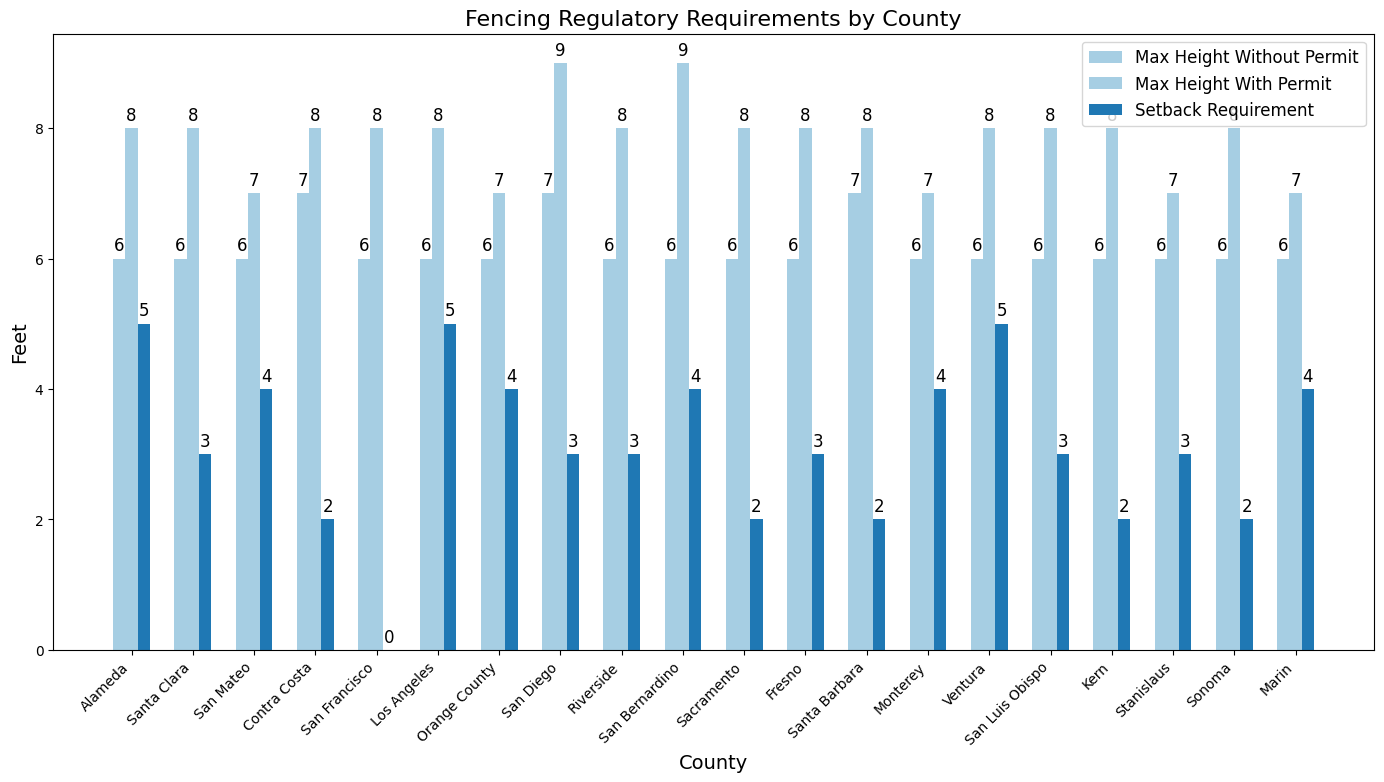How many counties have a setback requirement of 3 feet? To find this, count the number of bars representing 3 feet in height for the "Setback Requirement" across all counties.
Answer: 5 Which county has the tallest maximum fence height without a permit? Identify the highest bar for the "Max Height Without Permit" and note the corresponding county.
Answer: Santa Barbara Which county requires the highest setback requirement for installing a fence? Look for the tallest bar in the "Setback Requirement" category and identify the corresponding county.
Answer: Alameda, Ventura (tie) Which two counties allow the same maximum fence height without a permit? Compare the heights of the "Max Height Without Permit" bars and find two counties with bars of the same height.
Answer: Riverside, San Bernardino What is the average maximum fence height with a permit across all counties? Sum all the "Max Height With Permit" values and divide by the total number of counties. The values are 8+8+7+8+8+8+7+9+8+9+8+8+8+7+8+8+8+7+8 = 147. Divide by 19 (number of counties) to get the average.
Answer: 7.74 Which county has the smallest difference between the max height with and without a permit? Calculate the difference between "Max Height With Permit" and "Max Height Without Permit" for each county and identify the county with the smallest value. Differences are Conds:
Alameda: 8-6=2, Santa Clara: 8-6=2, San Mateo: 7-6=1, Contra Costa: 8-7=1,
San Francisco: 8-6=2, Los Angeles: 8-6=2, Orange County: 7-6=1,
San Diego: 9-7=2, Riverside: 8-6=2, San Bernardino: 9-6=3, Sacramento: 8-6=2,
Fresno: 8-6=2, Santa Barbara: 8-7=1, Monterey: 7-6=1, Ventura: 8-6=2, 
San Luis Obispo: 8-6=2, Kern: 8-6=2, Stanislaus: 7-6=1, Sonoma: 8-6=2, Marin: 7-6=1
Marin: 7-6 = 1
Answer: San Mateo, Contra Costa, Orange County, Santa Barbara, Monterey, Stanislaus, Marin (tie) Which county does not require a permit but allows a maximum fence height of 9 feet with a permit? Check the counties whose "Max Height With Permit" bar is at 9 feet and see which ones don't have "Permit Required."
Answer: San Diego, San Bernardino (tie) What visual difference can you observe about the setback requirements in comparison to the other two categories? Compare the height and spacing of bars in the "Setback Requirement" series to the bars in the "Max Height Without Permit" and "Max Height With Permit" series.
Answer: Setback requirements are generally lower across counties 